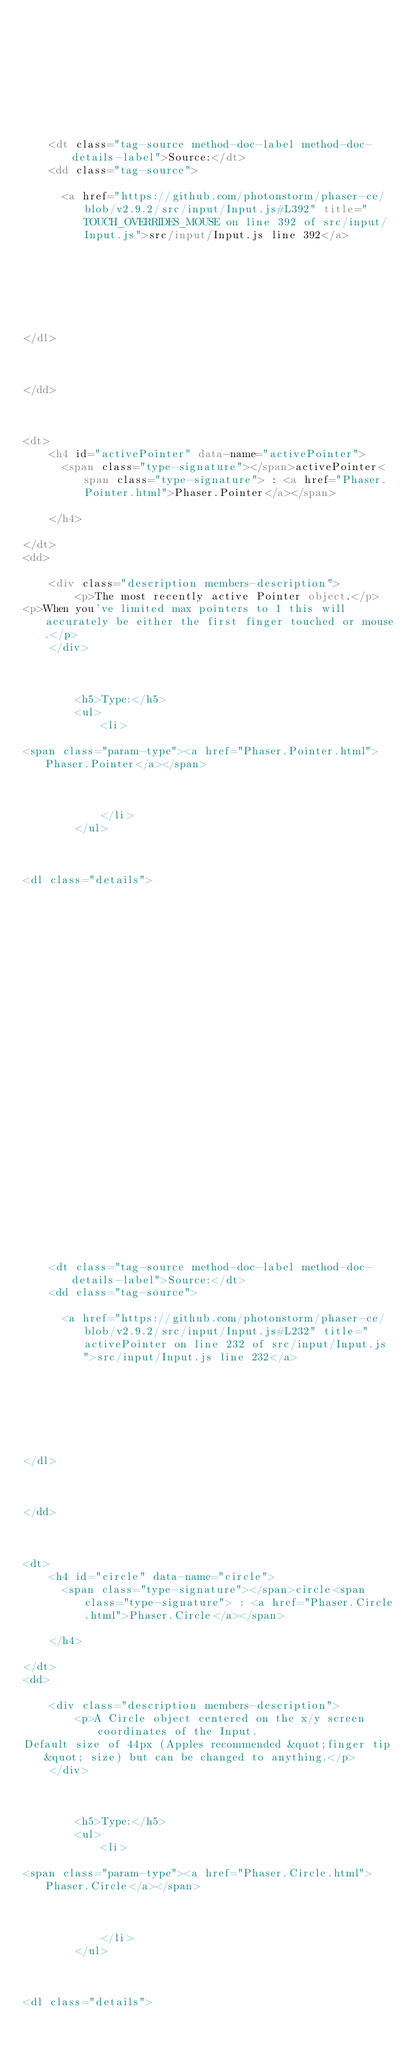<code> <loc_0><loc_0><loc_500><loc_500><_HTML_>	

	

	



	
	<dt class="tag-source method-doc-label method-doc-details-label">Source:</dt>
	<dd class="tag-source">
    
      <a href="https://github.com/photonstorm/phaser-ce/blob/v2.9.2/src/input/Input.js#L392" title="TOUCH_OVERRIDES_MOUSE on line 392 of src/input/Input.js">src/input/Input.js line 392</a>
    

	

	

	
</dl>


    
</dd>

        
            
<dt>
    <h4 id="activePointer" data-name="activePointer">
      <span class="type-signature"></span>activePointer<span class="type-signature"> : <a href="Phaser.Pointer.html">Phaser.Pointer</a></span>
      
    </h4>
    
</dt>
<dd>
    
    <div class="description members-description">
        <p>The most recently active Pointer object.</p>
<p>When you've limited max pointers to 1 this will accurately be either the first finger touched or mouse.</p>
    </div>
    

    
        <h5>Type:</h5>
        <ul>
            <li>
                
<span class="param-type"><a href="Phaser.Pointer.html">Phaser.Pointer</a></span>



            </li>
        </ul>
    

    
<dl class="details">
    

	

	

	

    

    

    

    

	

	

	

	

	



	
	<dt class="tag-source method-doc-label method-doc-details-label">Source:</dt>
	<dd class="tag-source">
    
      <a href="https://github.com/photonstorm/phaser-ce/blob/v2.9.2/src/input/Input.js#L232" title="activePointer on line 232 of src/input/Input.js">src/input/Input.js line 232</a>
    

	

	

	
</dl>


    
</dd>

        
            
<dt>
    <h4 id="circle" data-name="circle">
      <span class="type-signature"></span>circle<span class="type-signature"> : <a href="Phaser.Circle.html">Phaser.Circle</a></span>
      
    </h4>
    
</dt>
<dd>
    
    <div class="description members-description">
        <p>A Circle object centered on the x/y screen coordinates of the Input.
Default size of 44px (Apples recommended &quot;finger tip&quot; size) but can be changed to anything.</p>
    </div>
    

    
        <h5>Type:</h5>
        <ul>
            <li>
                
<span class="param-type"><a href="Phaser.Circle.html">Phaser.Circle</a></span>



            </li>
        </ul>
    

    
<dl class="details">
    

	

	
</code> 